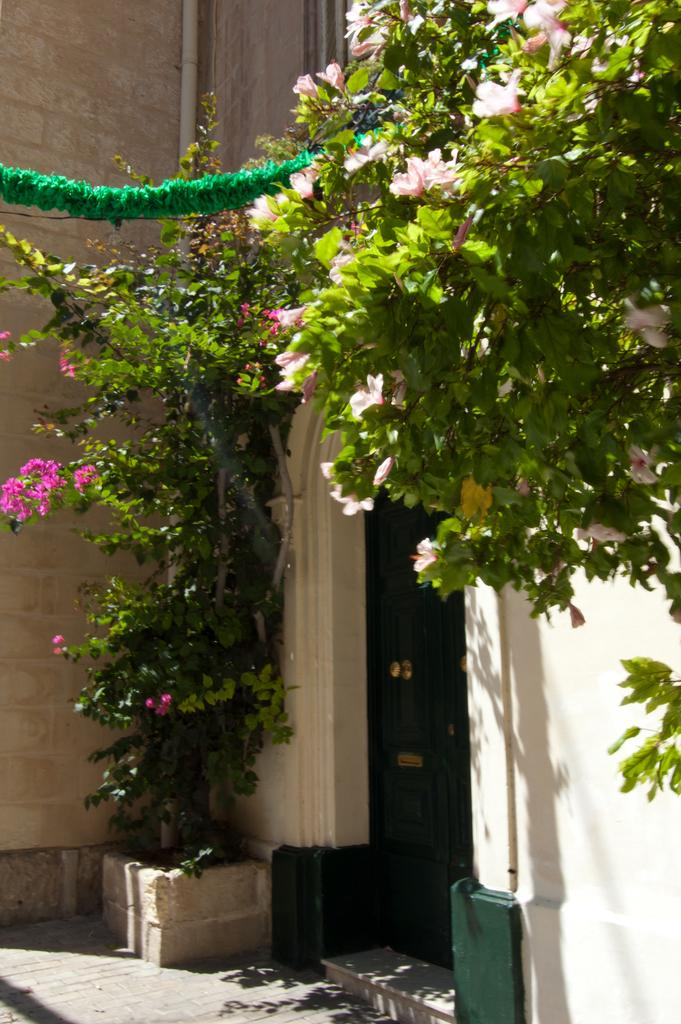What is the main object in the image? There is a closed door in the image. What else can be seen in the image besides the door? There is a wall, a pipe, plants, and flowers in the image. Can you describe the pipe in the image? The pipe is a long, cylindrical object in the image. What type of vegetation is present in the image? There are plants and flowers in the image. What type of net is being used to catch the flowers in the image? There is no net present in the image, and the flowers are not being caught. 